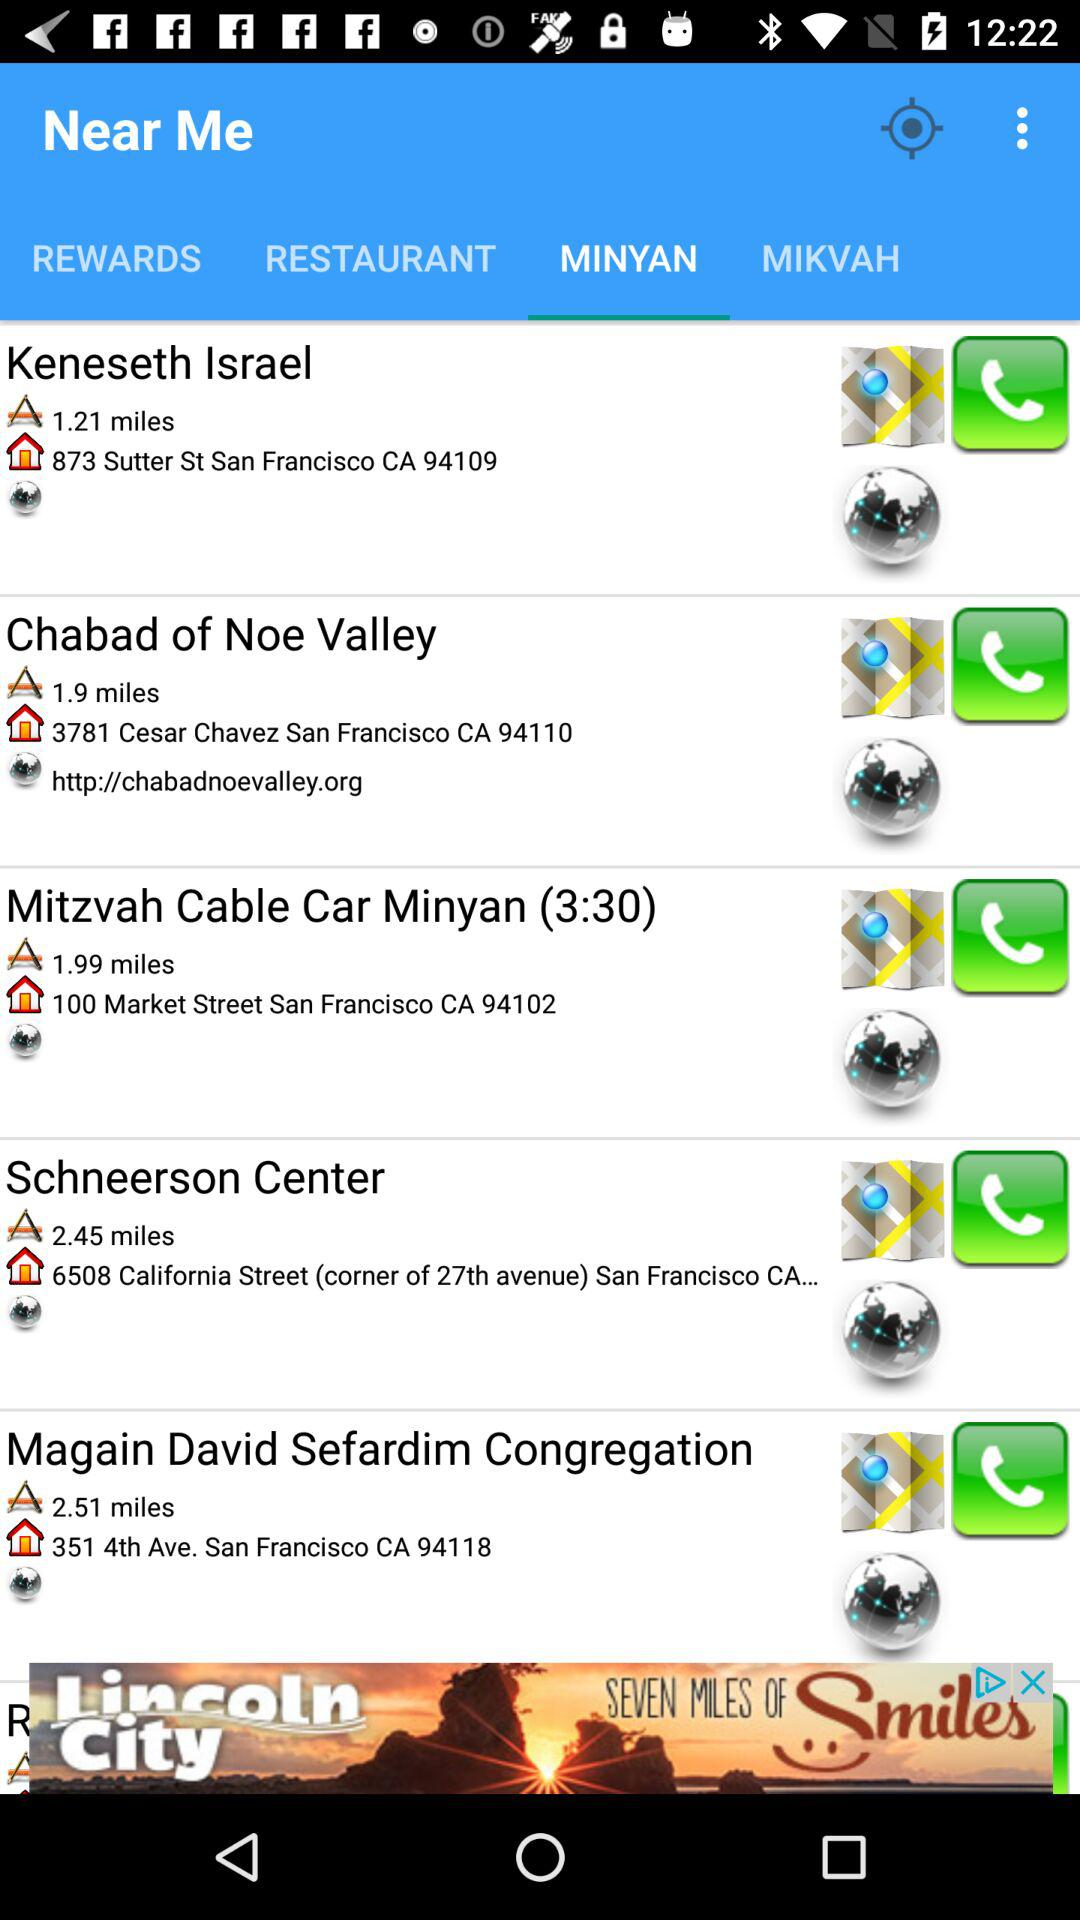What is the address of the Schneerson Center? The address of the Schneerson Center is "6508 California Street (corner of 27th avenue) San Francisco CA...". 